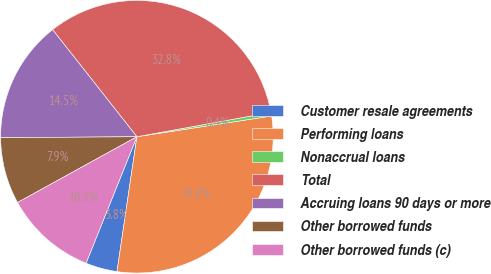<chart> <loc_0><loc_0><loc_500><loc_500><pie_chart><fcel>Customer resale agreements<fcel>Performing loans<fcel>Nonaccrual loans<fcel>Total<fcel>Accruing loans 90 days or more<fcel>Other borrowed funds<fcel>Other borrowed funds (c)<nl><fcel>3.75%<fcel>29.76%<fcel>0.43%<fcel>32.76%<fcel>14.5%<fcel>7.9%<fcel>10.9%<nl></chart> 